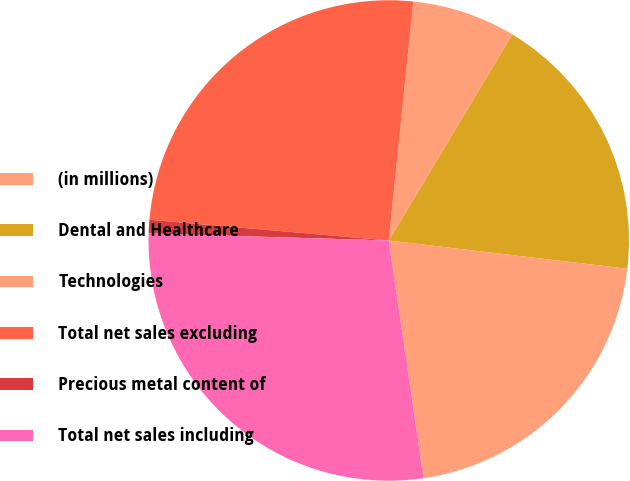Convert chart. <chart><loc_0><loc_0><loc_500><loc_500><pie_chart><fcel>(in millions)<fcel>Dental and Healthcare<fcel>Technologies<fcel>Total net sales excluding<fcel>Precious metal content of<fcel>Total net sales including<nl><fcel>20.81%<fcel>18.28%<fcel>6.97%<fcel>25.25%<fcel>0.91%<fcel>27.78%<nl></chart> 